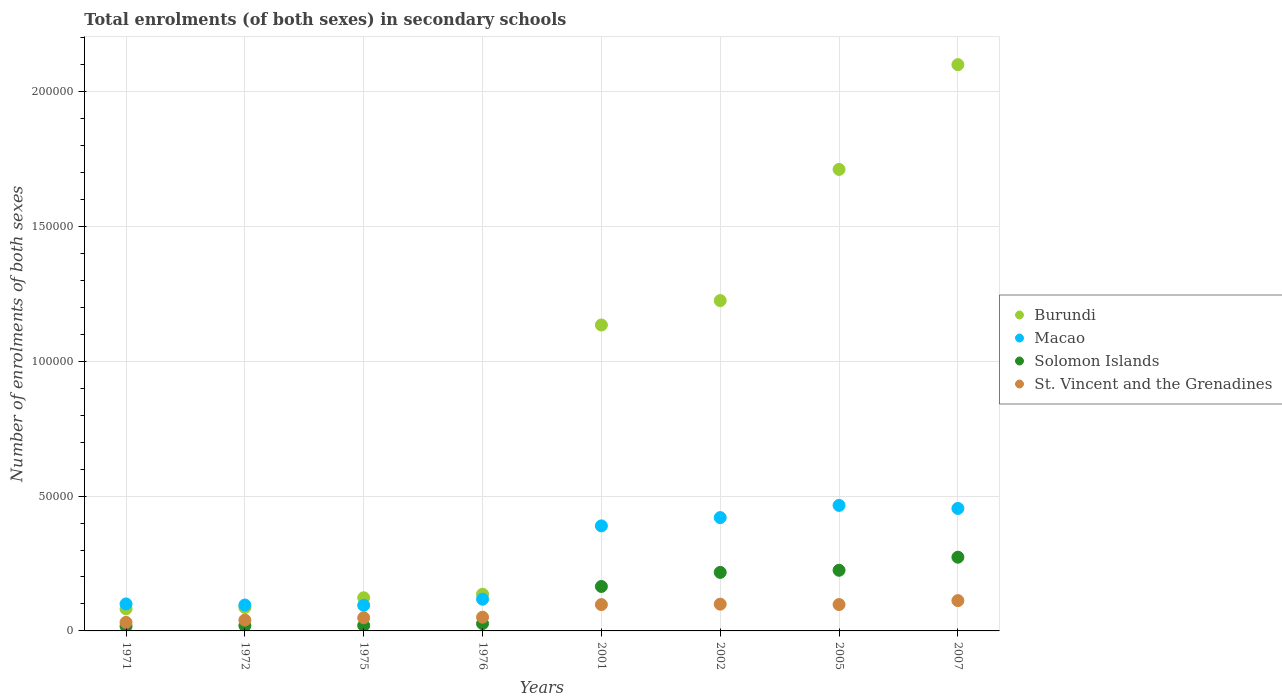How many different coloured dotlines are there?
Your answer should be very brief. 4. What is the number of enrolments in secondary schools in Solomon Islands in 1976?
Offer a very short reply. 2725. Across all years, what is the maximum number of enrolments in secondary schools in Solomon Islands?
Give a very brief answer. 2.73e+04. Across all years, what is the minimum number of enrolments in secondary schools in Burundi?
Your answer should be compact. 8169. In which year was the number of enrolments in secondary schools in Macao minimum?
Provide a succinct answer. 1975. What is the total number of enrolments in secondary schools in Solomon Islands in the graph?
Provide a succinct answer. 9.64e+04. What is the difference between the number of enrolments in secondary schools in Solomon Islands in 1971 and that in 2007?
Your answer should be very brief. -2.56e+04. What is the difference between the number of enrolments in secondary schools in Macao in 1975 and the number of enrolments in secondary schools in Burundi in 1972?
Keep it short and to the point. 820. What is the average number of enrolments in secondary schools in Macao per year?
Keep it short and to the point. 2.67e+04. In the year 2007, what is the difference between the number of enrolments in secondary schools in Solomon Islands and number of enrolments in secondary schools in Macao?
Your answer should be very brief. -1.81e+04. In how many years, is the number of enrolments in secondary schools in St. Vincent and the Grenadines greater than 120000?
Your answer should be very brief. 0. What is the ratio of the number of enrolments in secondary schools in Macao in 1972 to that in 2002?
Your answer should be compact. 0.23. Is the difference between the number of enrolments in secondary schools in Solomon Islands in 1971 and 1976 greater than the difference between the number of enrolments in secondary schools in Macao in 1971 and 1976?
Your answer should be very brief. Yes. What is the difference between the highest and the second highest number of enrolments in secondary schools in Macao?
Offer a very short reply. 1129. What is the difference between the highest and the lowest number of enrolments in secondary schools in Macao?
Keep it short and to the point. 3.70e+04. In how many years, is the number of enrolments in secondary schools in Macao greater than the average number of enrolments in secondary schools in Macao taken over all years?
Give a very brief answer. 4. Is the sum of the number of enrolments in secondary schools in Solomon Islands in 1975 and 2005 greater than the maximum number of enrolments in secondary schools in Burundi across all years?
Make the answer very short. No. Is it the case that in every year, the sum of the number of enrolments in secondary schools in Solomon Islands and number of enrolments in secondary schools in St. Vincent and the Grenadines  is greater than the sum of number of enrolments in secondary schools in Macao and number of enrolments in secondary schools in Burundi?
Your answer should be very brief. No. Is it the case that in every year, the sum of the number of enrolments in secondary schools in Macao and number of enrolments in secondary schools in St. Vincent and the Grenadines  is greater than the number of enrolments in secondary schools in Burundi?
Your answer should be compact. No. Does the number of enrolments in secondary schools in Solomon Islands monotonically increase over the years?
Your response must be concise. Yes. Is the number of enrolments in secondary schools in Solomon Islands strictly less than the number of enrolments in secondary schools in Macao over the years?
Offer a terse response. Yes. How many dotlines are there?
Offer a very short reply. 4. How many years are there in the graph?
Ensure brevity in your answer.  8. Are the values on the major ticks of Y-axis written in scientific E-notation?
Give a very brief answer. No. Does the graph contain any zero values?
Offer a very short reply. No. Where does the legend appear in the graph?
Your answer should be compact. Center right. How many legend labels are there?
Your answer should be compact. 4. How are the legend labels stacked?
Your response must be concise. Vertical. What is the title of the graph?
Make the answer very short. Total enrolments (of both sexes) in secondary schools. What is the label or title of the X-axis?
Give a very brief answer. Years. What is the label or title of the Y-axis?
Offer a very short reply. Number of enrolments of both sexes. What is the Number of enrolments of both sexes of Burundi in 1971?
Ensure brevity in your answer.  8169. What is the Number of enrolments of both sexes in Macao in 1971?
Ensure brevity in your answer.  1.00e+04. What is the Number of enrolments of both sexes of Solomon Islands in 1971?
Make the answer very short. 1720. What is the Number of enrolments of both sexes of St. Vincent and the Grenadines in 1971?
Your response must be concise. 3158. What is the Number of enrolments of both sexes in Burundi in 1972?
Provide a short and direct response. 8678. What is the Number of enrolments of both sexes in Macao in 1972?
Give a very brief answer. 9606. What is the Number of enrolments of both sexes in Solomon Islands in 1972?
Provide a short and direct response. 1943. What is the Number of enrolments of both sexes of St. Vincent and the Grenadines in 1972?
Your answer should be very brief. 4009. What is the Number of enrolments of both sexes in Burundi in 1975?
Provide a succinct answer. 1.23e+04. What is the Number of enrolments of both sexes of Macao in 1975?
Make the answer very short. 9498. What is the Number of enrolments of both sexes in Solomon Islands in 1975?
Keep it short and to the point. 2014. What is the Number of enrolments of both sexes of St. Vincent and the Grenadines in 1975?
Make the answer very short. 4878. What is the Number of enrolments of both sexes of Burundi in 1976?
Keep it short and to the point. 1.36e+04. What is the Number of enrolments of both sexes of Macao in 1976?
Keep it short and to the point. 1.18e+04. What is the Number of enrolments of both sexes of Solomon Islands in 1976?
Give a very brief answer. 2725. What is the Number of enrolments of both sexes in St. Vincent and the Grenadines in 1976?
Make the answer very short. 5084. What is the Number of enrolments of both sexes of Burundi in 2001?
Offer a very short reply. 1.13e+05. What is the Number of enrolments of both sexes of Macao in 2001?
Offer a terse response. 3.89e+04. What is the Number of enrolments of both sexes of Solomon Islands in 2001?
Your response must be concise. 1.65e+04. What is the Number of enrolments of both sexes of St. Vincent and the Grenadines in 2001?
Give a very brief answer. 9756. What is the Number of enrolments of both sexes in Burundi in 2002?
Your answer should be very brief. 1.22e+05. What is the Number of enrolments of both sexes in Macao in 2002?
Ensure brevity in your answer.  4.20e+04. What is the Number of enrolments of both sexes of Solomon Islands in 2002?
Ensure brevity in your answer.  2.17e+04. What is the Number of enrolments of both sexes of St. Vincent and the Grenadines in 2002?
Give a very brief answer. 9920. What is the Number of enrolments of both sexes of Burundi in 2005?
Your answer should be very brief. 1.71e+05. What is the Number of enrolments of both sexes in Macao in 2005?
Your answer should be very brief. 4.65e+04. What is the Number of enrolments of both sexes in Solomon Islands in 2005?
Your response must be concise. 2.25e+04. What is the Number of enrolments of both sexes of St. Vincent and the Grenadines in 2005?
Keep it short and to the point. 9780. What is the Number of enrolments of both sexes in Burundi in 2007?
Ensure brevity in your answer.  2.10e+05. What is the Number of enrolments of both sexes of Macao in 2007?
Provide a succinct answer. 4.54e+04. What is the Number of enrolments of both sexes of Solomon Islands in 2007?
Your answer should be compact. 2.73e+04. What is the Number of enrolments of both sexes of St. Vincent and the Grenadines in 2007?
Your answer should be compact. 1.12e+04. Across all years, what is the maximum Number of enrolments of both sexes of Burundi?
Offer a terse response. 2.10e+05. Across all years, what is the maximum Number of enrolments of both sexes of Macao?
Your answer should be very brief. 4.65e+04. Across all years, what is the maximum Number of enrolments of both sexes in Solomon Islands?
Offer a very short reply. 2.73e+04. Across all years, what is the maximum Number of enrolments of both sexes of St. Vincent and the Grenadines?
Make the answer very short. 1.12e+04. Across all years, what is the minimum Number of enrolments of both sexes in Burundi?
Give a very brief answer. 8169. Across all years, what is the minimum Number of enrolments of both sexes in Macao?
Keep it short and to the point. 9498. Across all years, what is the minimum Number of enrolments of both sexes in Solomon Islands?
Ensure brevity in your answer.  1720. Across all years, what is the minimum Number of enrolments of both sexes in St. Vincent and the Grenadines?
Give a very brief answer. 3158. What is the total Number of enrolments of both sexes in Burundi in the graph?
Your answer should be compact. 6.60e+05. What is the total Number of enrolments of both sexes of Macao in the graph?
Give a very brief answer. 2.14e+05. What is the total Number of enrolments of both sexes in Solomon Islands in the graph?
Ensure brevity in your answer.  9.64e+04. What is the total Number of enrolments of both sexes of St. Vincent and the Grenadines in the graph?
Offer a terse response. 5.78e+04. What is the difference between the Number of enrolments of both sexes of Burundi in 1971 and that in 1972?
Make the answer very short. -509. What is the difference between the Number of enrolments of both sexes of Macao in 1971 and that in 1972?
Provide a short and direct response. 401. What is the difference between the Number of enrolments of both sexes of Solomon Islands in 1971 and that in 1972?
Offer a very short reply. -223. What is the difference between the Number of enrolments of both sexes of St. Vincent and the Grenadines in 1971 and that in 1972?
Ensure brevity in your answer.  -851. What is the difference between the Number of enrolments of both sexes in Burundi in 1971 and that in 1975?
Keep it short and to the point. -4128. What is the difference between the Number of enrolments of both sexes of Macao in 1971 and that in 1975?
Offer a terse response. 509. What is the difference between the Number of enrolments of both sexes of Solomon Islands in 1971 and that in 1975?
Make the answer very short. -294. What is the difference between the Number of enrolments of both sexes in St. Vincent and the Grenadines in 1971 and that in 1975?
Make the answer very short. -1720. What is the difference between the Number of enrolments of both sexes in Burundi in 1971 and that in 1976?
Make the answer very short. -5454. What is the difference between the Number of enrolments of both sexes of Macao in 1971 and that in 1976?
Give a very brief answer. -1751. What is the difference between the Number of enrolments of both sexes of Solomon Islands in 1971 and that in 1976?
Ensure brevity in your answer.  -1005. What is the difference between the Number of enrolments of both sexes in St. Vincent and the Grenadines in 1971 and that in 1976?
Keep it short and to the point. -1926. What is the difference between the Number of enrolments of both sexes in Burundi in 1971 and that in 2001?
Ensure brevity in your answer.  -1.05e+05. What is the difference between the Number of enrolments of both sexes in Macao in 1971 and that in 2001?
Your answer should be very brief. -2.89e+04. What is the difference between the Number of enrolments of both sexes of Solomon Islands in 1971 and that in 2001?
Your response must be concise. -1.48e+04. What is the difference between the Number of enrolments of both sexes in St. Vincent and the Grenadines in 1971 and that in 2001?
Keep it short and to the point. -6598. What is the difference between the Number of enrolments of both sexes of Burundi in 1971 and that in 2002?
Give a very brief answer. -1.14e+05. What is the difference between the Number of enrolments of both sexes in Macao in 1971 and that in 2002?
Ensure brevity in your answer.  -3.20e+04. What is the difference between the Number of enrolments of both sexes of Solomon Islands in 1971 and that in 2002?
Offer a terse response. -2.00e+04. What is the difference between the Number of enrolments of both sexes of St. Vincent and the Grenadines in 1971 and that in 2002?
Give a very brief answer. -6762. What is the difference between the Number of enrolments of both sexes in Burundi in 1971 and that in 2005?
Your response must be concise. -1.63e+05. What is the difference between the Number of enrolments of both sexes of Macao in 1971 and that in 2005?
Give a very brief answer. -3.65e+04. What is the difference between the Number of enrolments of both sexes of Solomon Islands in 1971 and that in 2005?
Provide a short and direct response. -2.08e+04. What is the difference between the Number of enrolments of both sexes of St. Vincent and the Grenadines in 1971 and that in 2005?
Your answer should be compact. -6622. What is the difference between the Number of enrolments of both sexes in Burundi in 1971 and that in 2007?
Ensure brevity in your answer.  -2.02e+05. What is the difference between the Number of enrolments of both sexes in Macao in 1971 and that in 2007?
Offer a very short reply. -3.54e+04. What is the difference between the Number of enrolments of both sexes of Solomon Islands in 1971 and that in 2007?
Provide a succinct answer. -2.56e+04. What is the difference between the Number of enrolments of both sexes of St. Vincent and the Grenadines in 1971 and that in 2007?
Give a very brief answer. -8080. What is the difference between the Number of enrolments of both sexes in Burundi in 1972 and that in 1975?
Your answer should be compact. -3619. What is the difference between the Number of enrolments of both sexes in Macao in 1972 and that in 1975?
Make the answer very short. 108. What is the difference between the Number of enrolments of both sexes of Solomon Islands in 1972 and that in 1975?
Your answer should be very brief. -71. What is the difference between the Number of enrolments of both sexes of St. Vincent and the Grenadines in 1972 and that in 1975?
Make the answer very short. -869. What is the difference between the Number of enrolments of both sexes of Burundi in 1972 and that in 1976?
Make the answer very short. -4945. What is the difference between the Number of enrolments of both sexes of Macao in 1972 and that in 1976?
Your response must be concise. -2152. What is the difference between the Number of enrolments of both sexes of Solomon Islands in 1972 and that in 1976?
Provide a short and direct response. -782. What is the difference between the Number of enrolments of both sexes of St. Vincent and the Grenadines in 1972 and that in 1976?
Provide a short and direct response. -1075. What is the difference between the Number of enrolments of both sexes in Burundi in 1972 and that in 2001?
Ensure brevity in your answer.  -1.05e+05. What is the difference between the Number of enrolments of both sexes in Macao in 1972 and that in 2001?
Make the answer very short. -2.93e+04. What is the difference between the Number of enrolments of both sexes in Solomon Islands in 1972 and that in 2001?
Your answer should be very brief. -1.45e+04. What is the difference between the Number of enrolments of both sexes of St. Vincent and the Grenadines in 1972 and that in 2001?
Keep it short and to the point. -5747. What is the difference between the Number of enrolments of both sexes in Burundi in 1972 and that in 2002?
Ensure brevity in your answer.  -1.14e+05. What is the difference between the Number of enrolments of both sexes in Macao in 1972 and that in 2002?
Give a very brief answer. -3.24e+04. What is the difference between the Number of enrolments of both sexes in Solomon Islands in 1972 and that in 2002?
Keep it short and to the point. -1.98e+04. What is the difference between the Number of enrolments of both sexes of St. Vincent and the Grenadines in 1972 and that in 2002?
Your answer should be compact. -5911. What is the difference between the Number of enrolments of both sexes in Burundi in 1972 and that in 2005?
Make the answer very short. -1.62e+05. What is the difference between the Number of enrolments of both sexes of Macao in 1972 and that in 2005?
Your answer should be compact. -3.69e+04. What is the difference between the Number of enrolments of both sexes of Solomon Islands in 1972 and that in 2005?
Give a very brief answer. -2.05e+04. What is the difference between the Number of enrolments of both sexes in St. Vincent and the Grenadines in 1972 and that in 2005?
Your answer should be very brief. -5771. What is the difference between the Number of enrolments of both sexes of Burundi in 1972 and that in 2007?
Provide a succinct answer. -2.01e+05. What is the difference between the Number of enrolments of both sexes in Macao in 1972 and that in 2007?
Make the answer very short. -3.58e+04. What is the difference between the Number of enrolments of both sexes in Solomon Islands in 1972 and that in 2007?
Offer a terse response. -2.54e+04. What is the difference between the Number of enrolments of both sexes of St. Vincent and the Grenadines in 1972 and that in 2007?
Ensure brevity in your answer.  -7229. What is the difference between the Number of enrolments of both sexes in Burundi in 1975 and that in 1976?
Your answer should be very brief. -1326. What is the difference between the Number of enrolments of both sexes of Macao in 1975 and that in 1976?
Ensure brevity in your answer.  -2260. What is the difference between the Number of enrolments of both sexes of Solomon Islands in 1975 and that in 1976?
Provide a succinct answer. -711. What is the difference between the Number of enrolments of both sexes in St. Vincent and the Grenadines in 1975 and that in 1976?
Your answer should be very brief. -206. What is the difference between the Number of enrolments of both sexes of Burundi in 1975 and that in 2001?
Offer a terse response. -1.01e+05. What is the difference between the Number of enrolments of both sexes in Macao in 1975 and that in 2001?
Ensure brevity in your answer.  -2.94e+04. What is the difference between the Number of enrolments of both sexes in Solomon Islands in 1975 and that in 2001?
Offer a terse response. -1.45e+04. What is the difference between the Number of enrolments of both sexes of St. Vincent and the Grenadines in 1975 and that in 2001?
Your answer should be compact. -4878. What is the difference between the Number of enrolments of both sexes of Burundi in 1975 and that in 2002?
Make the answer very short. -1.10e+05. What is the difference between the Number of enrolments of both sexes of Macao in 1975 and that in 2002?
Make the answer very short. -3.25e+04. What is the difference between the Number of enrolments of both sexes of Solomon Islands in 1975 and that in 2002?
Offer a very short reply. -1.97e+04. What is the difference between the Number of enrolments of both sexes of St. Vincent and the Grenadines in 1975 and that in 2002?
Your answer should be compact. -5042. What is the difference between the Number of enrolments of both sexes in Burundi in 1975 and that in 2005?
Your answer should be compact. -1.59e+05. What is the difference between the Number of enrolments of both sexes in Macao in 1975 and that in 2005?
Keep it short and to the point. -3.70e+04. What is the difference between the Number of enrolments of both sexes of Solomon Islands in 1975 and that in 2005?
Offer a very short reply. -2.05e+04. What is the difference between the Number of enrolments of both sexes in St. Vincent and the Grenadines in 1975 and that in 2005?
Provide a succinct answer. -4902. What is the difference between the Number of enrolments of both sexes of Burundi in 1975 and that in 2007?
Offer a very short reply. -1.98e+05. What is the difference between the Number of enrolments of both sexes in Macao in 1975 and that in 2007?
Provide a succinct answer. -3.59e+04. What is the difference between the Number of enrolments of both sexes of Solomon Islands in 1975 and that in 2007?
Ensure brevity in your answer.  -2.53e+04. What is the difference between the Number of enrolments of both sexes in St. Vincent and the Grenadines in 1975 and that in 2007?
Offer a terse response. -6360. What is the difference between the Number of enrolments of both sexes of Burundi in 1976 and that in 2001?
Offer a very short reply. -9.98e+04. What is the difference between the Number of enrolments of both sexes in Macao in 1976 and that in 2001?
Provide a short and direct response. -2.72e+04. What is the difference between the Number of enrolments of both sexes in Solomon Islands in 1976 and that in 2001?
Provide a short and direct response. -1.38e+04. What is the difference between the Number of enrolments of both sexes of St. Vincent and the Grenadines in 1976 and that in 2001?
Ensure brevity in your answer.  -4672. What is the difference between the Number of enrolments of both sexes in Burundi in 1976 and that in 2002?
Your answer should be compact. -1.09e+05. What is the difference between the Number of enrolments of both sexes in Macao in 1976 and that in 2002?
Your response must be concise. -3.03e+04. What is the difference between the Number of enrolments of both sexes of Solomon Islands in 1976 and that in 2002?
Offer a very short reply. -1.90e+04. What is the difference between the Number of enrolments of both sexes of St. Vincent and the Grenadines in 1976 and that in 2002?
Give a very brief answer. -4836. What is the difference between the Number of enrolments of both sexes in Burundi in 1976 and that in 2005?
Your answer should be very brief. -1.57e+05. What is the difference between the Number of enrolments of both sexes in Macao in 1976 and that in 2005?
Your response must be concise. -3.48e+04. What is the difference between the Number of enrolments of both sexes in Solomon Islands in 1976 and that in 2005?
Provide a short and direct response. -1.98e+04. What is the difference between the Number of enrolments of both sexes in St. Vincent and the Grenadines in 1976 and that in 2005?
Offer a very short reply. -4696. What is the difference between the Number of enrolments of both sexes of Burundi in 1976 and that in 2007?
Give a very brief answer. -1.96e+05. What is the difference between the Number of enrolments of both sexes of Macao in 1976 and that in 2007?
Give a very brief answer. -3.37e+04. What is the difference between the Number of enrolments of both sexes in Solomon Islands in 1976 and that in 2007?
Offer a very short reply. -2.46e+04. What is the difference between the Number of enrolments of both sexes in St. Vincent and the Grenadines in 1976 and that in 2007?
Give a very brief answer. -6154. What is the difference between the Number of enrolments of both sexes in Burundi in 2001 and that in 2002?
Keep it short and to the point. -9042. What is the difference between the Number of enrolments of both sexes in Macao in 2001 and that in 2002?
Make the answer very short. -3074. What is the difference between the Number of enrolments of both sexes in Solomon Islands in 2001 and that in 2002?
Provide a short and direct response. -5220. What is the difference between the Number of enrolments of both sexes of St. Vincent and the Grenadines in 2001 and that in 2002?
Provide a short and direct response. -164. What is the difference between the Number of enrolments of both sexes in Burundi in 2001 and that in 2005?
Provide a short and direct response. -5.77e+04. What is the difference between the Number of enrolments of both sexes of Macao in 2001 and that in 2005?
Provide a succinct answer. -7596. What is the difference between the Number of enrolments of both sexes of Solomon Islands in 2001 and that in 2005?
Make the answer very short. -6007. What is the difference between the Number of enrolments of both sexes in St. Vincent and the Grenadines in 2001 and that in 2005?
Offer a terse response. -24. What is the difference between the Number of enrolments of both sexes of Burundi in 2001 and that in 2007?
Give a very brief answer. -9.65e+04. What is the difference between the Number of enrolments of both sexes of Macao in 2001 and that in 2007?
Give a very brief answer. -6467. What is the difference between the Number of enrolments of both sexes of Solomon Islands in 2001 and that in 2007?
Your answer should be compact. -1.09e+04. What is the difference between the Number of enrolments of both sexes in St. Vincent and the Grenadines in 2001 and that in 2007?
Make the answer very short. -1482. What is the difference between the Number of enrolments of both sexes of Burundi in 2002 and that in 2005?
Your answer should be very brief. -4.86e+04. What is the difference between the Number of enrolments of both sexes in Macao in 2002 and that in 2005?
Make the answer very short. -4522. What is the difference between the Number of enrolments of both sexes in Solomon Islands in 2002 and that in 2005?
Keep it short and to the point. -787. What is the difference between the Number of enrolments of both sexes of St. Vincent and the Grenadines in 2002 and that in 2005?
Your answer should be compact. 140. What is the difference between the Number of enrolments of both sexes of Burundi in 2002 and that in 2007?
Your answer should be compact. -8.75e+04. What is the difference between the Number of enrolments of both sexes in Macao in 2002 and that in 2007?
Your answer should be very brief. -3393. What is the difference between the Number of enrolments of both sexes of Solomon Islands in 2002 and that in 2007?
Keep it short and to the point. -5632. What is the difference between the Number of enrolments of both sexes of St. Vincent and the Grenadines in 2002 and that in 2007?
Give a very brief answer. -1318. What is the difference between the Number of enrolments of both sexes in Burundi in 2005 and that in 2007?
Offer a very short reply. -3.88e+04. What is the difference between the Number of enrolments of both sexes of Macao in 2005 and that in 2007?
Give a very brief answer. 1129. What is the difference between the Number of enrolments of both sexes in Solomon Islands in 2005 and that in 2007?
Provide a short and direct response. -4845. What is the difference between the Number of enrolments of both sexes of St. Vincent and the Grenadines in 2005 and that in 2007?
Your answer should be very brief. -1458. What is the difference between the Number of enrolments of both sexes of Burundi in 1971 and the Number of enrolments of both sexes of Macao in 1972?
Make the answer very short. -1437. What is the difference between the Number of enrolments of both sexes in Burundi in 1971 and the Number of enrolments of both sexes in Solomon Islands in 1972?
Your answer should be compact. 6226. What is the difference between the Number of enrolments of both sexes in Burundi in 1971 and the Number of enrolments of both sexes in St. Vincent and the Grenadines in 1972?
Offer a very short reply. 4160. What is the difference between the Number of enrolments of both sexes of Macao in 1971 and the Number of enrolments of both sexes of Solomon Islands in 1972?
Your answer should be very brief. 8064. What is the difference between the Number of enrolments of both sexes of Macao in 1971 and the Number of enrolments of both sexes of St. Vincent and the Grenadines in 1972?
Your response must be concise. 5998. What is the difference between the Number of enrolments of both sexes of Solomon Islands in 1971 and the Number of enrolments of both sexes of St. Vincent and the Grenadines in 1972?
Make the answer very short. -2289. What is the difference between the Number of enrolments of both sexes of Burundi in 1971 and the Number of enrolments of both sexes of Macao in 1975?
Your response must be concise. -1329. What is the difference between the Number of enrolments of both sexes of Burundi in 1971 and the Number of enrolments of both sexes of Solomon Islands in 1975?
Give a very brief answer. 6155. What is the difference between the Number of enrolments of both sexes of Burundi in 1971 and the Number of enrolments of both sexes of St. Vincent and the Grenadines in 1975?
Make the answer very short. 3291. What is the difference between the Number of enrolments of both sexes in Macao in 1971 and the Number of enrolments of both sexes in Solomon Islands in 1975?
Make the answer very short. 7993. What is the difference between the Number of enrolments of both sexes of Macao in 1971 and the Number of enrolments of both sexes of St. Vincent and the Grenadines in 1975?
Offer a very short reply. 5129. What is the difference between the Number of enrolments of both sexes in Solomon Islands in 1971 and the Number of enrolments of both sexes in St. Vincent and the Grenadines in 1975?
Your answer should be very brief. -3158. What is the difference between the Number of enrolments of both sexes in Burundi in 1971 and the Number of enrolments of both sexes in Macao in 1976?
Offer a very short reply. -3589. What is the difference between the Number of enrolments of both sexes in Burundi in 1971 and the Number of enrolments of both sexes in Solomon Islands in 1976?
Keep it short and to the point. 5444. What is the difference between the Number of enrolments of both sexes in Burundi in 1971 and the Number of enrolments of both sexes in St. Vincent and the Grenadines in 1976?
Your response must be concise. 3085. What is the difference between the Number of enrolments of both sexes of Macao in 1971 and the Number of enrolments of both sexes of Solomon Islands in 1976?
Offer a terse response. 7282. What is the difference between the Number of enrolments of both sexes in Macao in 1971 and the Number of enrolments of both sexes in St. Vincent and the Grenadines in 1976?
Keep it short and to the point. 4923. What is the difference between the Number of enrolments of both sexes in Solomon Islands in 1971 and the Number of enrolments of both sexes in St. Vincent and the Grenadines in 1976?
Make the answer very short. -3364. What is the difference between the Number of enrolments of both sexes in Burundi in 1971 and the Number of enrolments of both sexes in Macao in 2001?
Ensure brevity in your answer.  -3.08e+04. What is the difference between the Number of enrolments of both sexes of Burundi in 1971 and the Number of enrolments of both sexes of Solomon Islands in 2001?
Make the answer very short. -8311. What is the difference between the Number of enrolments of both sexes in Burundi in 1971 and the Number of enrolments of both sexes in St. Vincent and the Grenadines in 2001?
Your answer should be compact. -1587. What is the difference between the Number of enrolments of both sexes of Macao in 1971 and the Number of enrolments of both sexes of Solomon Islands in 2001?
Your response must be concise. -6473. What is the difference between the Number of enrolments of both sexes in Macao in 1971 and the Number of enrolments of both sexes in St. Vincent and the Grenadines in 2001?
Offer a terse response. 251. What is the difference between the Number of enrolments of both sexes of Solomon Islands in 1971 and the Number of enrolments of both sexes of St. Vincent and the Grenadines in 2001?
Give a very brief answer. -8036. What is the difference between the Number of enrolments of both sexes of Burundi in 1971 and the Number of enrolments of both sexes of Macao in 2002?
Ensure brevity in your answer.  -3.38e+04. What is the difference between the Number of enrolments of both sexes in Burundi in 1971 and the Number of enrolments of both sexes in Solomon Islands in 2002?
Your response must be concise. -1.35e+04. What is the difference between the Number of enrolments of both sexes of Burundi in 1971 and the Number of enrolments of both sexes of St. Vincent and the Grenadines in 2002?
Your answer should be very brief. -1751. What is the difference between the Number of enrolments of both sexes of Macao in 1971 and the Number of enrolments of both sexes of Solomon Islands in 2002?
Your response must be concise. -1.17e+04. What is the difference between the Number of enrolments of both sexes of Solomon Islands in 1971 and the Number of enrolments of both sexes of St. Vincent and the Grenadines in 2002?
Give a very brief answer. -8200. What is the difference between the Number of enrolments of both sexes of Burundi in 1971 and the Number of enrolments of both sexes of Macao in 2005?
Your answer should be compact. -3.84e+04. What is the difference between the Number of enrolments of both sexes in Burundi in 1971 and the Number of enrolments of both sexes in Solomon Islands in 2005?
Offer a very short reply. -1.43e+04. What is the difference between the Number of enrolments of both sexes of Burundi in 1971 and the Number of enrolments of both sexes of St. Vincent and the Grenadines in 2005?
Provide a short and direct response. -1611. What is the difference between the Number of enrolments of both sexes of Macao in 1971 and the Number of enrolments of both sexes of Solomon Islands in 2005?
Your response must be concise. -1.25e+04. What is the difference between the Number of enrolments of both sexes in Macao in 1971 and the Number of enrolments of both sexes in St. Vincent and the Grenadines in 2005?
Offer a terse response. 227. What is the difference between the Number of enrolments of both sexes in Solomon Islands in 1971 and the Number of enrolments of both sexes in St. Vincent and the Grenadines in 2005?
Offer a terse response. -8060. What is the difference between the Number of enrolments of both sexes of Burundi in 1971 and the Number of enrolments of both sexes of Macao in 2007?
Your response must be concise. -3.72e+04. What is the difference between the Number of enrolments of both sexes in Burundi in 1971 and the Number of enrolments of both sexes in Solomon Islands in 2007?
Your response must be concise. -1.92e+04. What is the difference between the Number of enrolments of both sexes of Burundi in 1971 and the Number of enrolments of both sexes of St. Vincent and the Grenadines in 2007?
Provide a succinct answer. -3069. What is the difference between the Number of enrolments of both sexes in Macao in 1971 and the Number of enrolments of both sexes in Solomon Islands in 2007?
Provide a short and direct response. -1.73e+04. What is the difference between the Number of enrolments of both sexes of Macao in 1971 and the Number of enrolments of both sexes of St. Vincent and the Grenadines in 2007?
Provide a short and direct response. -1231. What is the difference between the Number of enrolments of both sexes in Solomon Islands in 1971 and the Number of enrolments of both sexes in St. Vincent and the Grenadines in 2007?
Your answer should be compact. -9518. What is the difference between the Number of enrolments of both sexes of Burundi in 1972 and the Number of enrolments of both sexes of Macao in 1975?
Make the answer very short. -820. What is the difference between the Number of enrolments of both sexes of Burundi in 1972 and the Number of enrolments of both sexes of Solomon Islands in 1975?
Provide a succinct answer. 6664. What is the difference between the Number of enrolments of both sexes in Burundi in 1972 and the Number of enrolments of both sexes in St. Vincent and the Grenadines in 1975?
Offer a very short reply. 3800. What is the difference between the Number of enrolments of both sexes of Macao in 1972 and the Number of enrolments of both sexes of Solomon Islands in 1975?
Ensure brevity in your answer.  7592. What is the difference between the Number of enrolments of both sexes in Macao in 1972 and the Number of enrolments of both sexes in St. Vincent and the Grenadines in 1975?
Your answer should be very brief. 4728. What is the difference between the Number of enrolments of both sexes in Solomon Islands in 1972 and the Number of enrolments of both sexes in St. Vincent and the Grenadines in 1975?
Your response must be concise. -2935. What is the difference between the Number of enrolments of both sexes in Burundi in 1972 and the Number of enrolments of both sexes in Macao in 1976?
Give a very brief answer. -3080. What is the difference between the Number of enrolments of both sexes in Burundi in 1972 and the Number of enrolments of both sexes in Solomon Islands in 1976?
Keep it short and to the point. 5953. What is the difference between the Number of enrolments of both sexes of Burundi in 1972 and the Number of enrolments of both sexes of St. Vincent and the Grenadines in 1976?
Offer a very short reply. 3594. What is the difference between the Number of enrolments of both sexes of Macao in 1972 and the Number of enrolments of both sexes of Solomon Islands in 1976?
Provide a short and direct response. 6881. What is the difference between the Number of enrolments of both sexes of Macao in 1972 and the Number of enrolments of both sexes of St. Vincent and the Grenadines in 1976?
Your answer should be compact. 4522. What is the difference between the Number of enrolments of both sexes of Solomon Islands in 1972 and the Number of enrolments of both sexes of St. Vincent and the Grenadines in 1976?
Make the answer very short. -3141. What is the difference between the Number of enrolments of both sexes of Burundi in 1972 and the Number of enrolments of both sexes of Macao in 2001?
Your answer should be very brief. -3.03e+04. What is the difference between the Number of enrolments of both sexes in Burundi in 1972 and the Number of enrolments of both sexes in Solomon Islands in 2001?
Give a very brief answer. -7802. What is the difference between the Number of enrolments of both sexes of Burundi in 1972 and the Number of enrolments of both sexes of St. Vincent and the Grenadines in 2001?
Make the answer very short. -1078. What is the difference between the Number of enrolments of both sexes of Macao in 1972 and the Number of enrolments of both sexes of Solomon Islands in 2001?
Provide a succinct answer. -6874. What is the difference between the Number of enrolments of both sexes of Macao in 1972 and the Number of enrolments of both sexes of St. Vincent and the Grenadines in 2001?
Offer a very short reply. -150. What is the difference between the Number of enrolments of both sexes in Solomon Islands in 1972 and the Number of enrolments of both sexes in St. Vincent and the Grenadines in 2001?
Your answer should be compact. -7813. What is the difference between the Number of enrolments of both sexes of Burundi in 1972 and the Number of enrolments of both sexes of Macao in 2002?
Ensure brevity in your answer.  -3.33e+04. What is the difference between the Number of enrolments of both sexes of Burundi in 1972 and the Number of enrolments of both sexes of Solomon Islands in 2002?
Offer a terse response. -1.30e+04. What is the difference between the Number of enrolments of both sexes of Burundi in 1972 and the Number of enrolments of both sexes of St. Vincent and the Grenadines in 2002?
Offer a terse response. -1242. What is the difference between the Number of enrolments of both sexes in Macao in 1972 and the Number of enrolments of both sexes in Solomon Islands in 2002?
Your answer should be compact. -1.21e+04. What is the difference between the Number of enrolments of both sexes in Macao in 1972 and the Number of enrolments of both sexes in St. Vincent and the Grenadines in 2002?
Provide a succinct answer. -314. What is the difference between the Number of enrolments of both sexes of Solomon Islands in 1972 and the Number of enrolments of both sexes of St. Vincent and the Grenadines in 2002?
Your answer should be very brief. -7977. What is the difference between the Number of enrolments of both sexes of Burundi in 1972 and the Number of enrolments of both sexes of Macao in 2005?
Your answer should be very brief. -3.79e+04. What is the difference between the Number of enrolments of both sexes of Burundi in 1972 and the Number of enrolments of both sexes of Solomon Islands in 2005?
Keep it short and to the point. -1.38e+04. What is the difference between the Number of enrolments of both sexes in Burundi in 1972 and the Number of enrolments of both sexes in St. Vincent and the Grenadines in 2005?
Provide a succinct answer. -1102. What is the difference between the Number of enrolments of both sexes in Macao in 1972 and the Number of enrolments of both sexes in Solomon Islands in 2005?
Offer a terse response. -1.29e+04. What is the difference between the Number of enrolments of both sexes in Macao in 1972 and the Number of enrolments of both sexes in St. Vincent and the Grenadines in 2005?
Provide a succinct answer. -174. What is the difference between the Number of enrolments of both sexes in Solomon Islands in 1972 and the Number of enrolments of both sexes in St. Vincent and the Grenadines in 2005?
Provide a short and direct response. -7837. What is the difference between the Number of enrolments of both sexes in Burundi in 1972 and the Number of enrolments of both sexes in Macao in 2007?
Offer a very short reply. -3.67e+04. What is the difference between the Number of enrolments of both sexes in Burundi in 1972 and the Number of enrolments of both sexes in Solomon Islands in 2007?
Offer a very short reply. -1.87e+04. What is the difference between the Number of enrolments of both sexes of Burundi in 1972 and the Number of enrolments of both sexes of St. Vincent and the Grenadines in 2007?
Keep it short and to the point. -2560. What is the difference between the Number of enrolments of both sexes of Macao in 1972 and the Number of enrolments of both sexes of Solomon Islands in 2007?
Offer a terse response. -1.77e+04. What is the difference between the Number of enrolments of both sexes of Macao in 1972 and the Number of enrolments of both sexes of St. Vincent and the Grenadines in 2007?
Keep it short and to the point. -1632. What is the difference between the Number of enrolments of both sexes of Solomon Islands in 1972 and the Number of enrolments of both sexes of St. Vincent and the Grenadines in 2007?
Ensure brevity in your answer.  -9295. What is the difference between the Number of enrolments of both sexes of Burundi in 1975 and the Number of enrolments of both sexes of Macao in 1976?
Provide a short and direct response. 539. What is the difference between the Number of enrolments of both sexes in Burundi in 1975 and the Number of enrolments of both sexes in Solomon Islands in 1976?
Offer a terse response. 9572. What is the difference between the Number of enrolments of both sexes in Burundi in 1975 and the Number of enrolments of both sexes in St. Vincent and the Grenadines in 1976?
Give a very brief answer. 7213. What is the difference between the Number of enrolments of both sexes in Macao in 1975 and the Number of enrolments of both sexes in Solomon Islands in 1976?
Provide a succinct answer. 6773. What is the difference between the Number of enrolments of both sexes in Macao in 1975 and the Number of enrolments of both sexes in St. Vincent and the Grenadines in 1976?
Make the answer very short. 4414. What is the difference between the Number of enrolments of both sexes in Solomon Islands in 1975 and the Number of enrolments of both sexes in St. Vincent and the Grenadines in 1976?
Keep it short and to the point. -3070. What is the difference between the Number of enrolments of both sexes of Burundi in 1975 and the Number of enrolments of both sexes of Macao in 2001?
Provide a short and direct response. -2.66e+04. What is the difference between the Number of enrolments of both sexes in Burundi in 1975 and the Number of enrolments of both sexes in Solomon Islands in 2001?
Your answer should be compact. -4183. What is the difference between the Number of enrolments of both sexes of Burundi in 1975 and the Number of enrolments of both sexes of St. Vincent and the Grenadines in 2001?
Ensure brevity in your answer.  2541. What is the difference between the Number of enrolments of both sexes of Macao in 1975 and the Number of enrolments of both sexes of Solomon Islands in 2001?
Provide a succinct answer. -6982. What is the difference between the Number of enrolments of both sexes of Macao in 1975 and the Number of enrolments of both sexes of St. Vincent and the Grenadines in 2001?
Give a very brief answer. -258. What is the difference between the Number of enrolments of both sexes of Solomon Islands in 1975 and the Number of enrolments of both sexes of St. Vincent and the Grenadines in 2001?
Ensure brevity in your answer.  -7742. What is the difference between the Number of enrolments of both sexes of Burundi in 1975 and the Number of enrolments of both sexes of Macao in 2002?
Ensure brevity in your answer.  -2.97e+04. What is the difference between the Number of enrolments of both sexes of Burundi in 1975 and the Number of enrolments of both sexes of Solomon Islands in 2002?
Provide a succinct answer. -9403. What is the difference between the Number of enrolments of both sexes of Burundi in 1975 and the Number of enrolments of both sexes of St. Vincent and the Grenadines in 2002?
Make the answer very short. 2377. What is the difference between the Number of enrolments of both sexes of Macao in 1975 and the Number of enrolments of both sexes of Solomon Islands in 2002?
Offer a very short reply. -1.22e+04. What is the difference between the Number of enrolments of both sexes of Macao in 1975 and the Number of enrolments of both sexes of St. Vincent and the Grenadines in 2002?
Ensure brevity in your answer.  -422. What is the difference between the Number of enrolments of both sexes of Solomon Islands in 1975 and the Number of enrolments of both sexes of St. Vincent and the Grenadines in 2002?
Offer a terse response. -7906. What is the difference between the Number of enrolments of both sexes of Burundi in 1975 and the Number of enrolments of both sexes of Macao in 2005?
Your response must be concise. -3.42e+04. What is the difference between the Number of enrolments of both sexes of Burundi in 1975 and the Number of enrolments of both sexes of Solomon Islands in 2005?
Your response must be concise. -1.02e+04. What is the difference between the Number of enrolments of both sexes in Burundi in 1975 and the Number of enrolments of both sexes in St. Vincent and the Grenadines in 2005?
Give a very brief answer. 2517. What is the difference between the Number of enrolments of both sexes in Macao in 1975 and the Number of enrolments of both sexes in Solomon Islands in 2005?
Give a very brief answer. -1.30e+04. What is the difference between the Number of enrolments of both sexes in Macao in 1975 and the Number of enrolments of both sexes in St. Vincent and the Grenadines in 2005?
Give a very brief answer. -282. What is the difference between the Number of enrolments of both sexes of Solomon Islands in 1975 and the Number of enrolments of both sexes of St. Vincent and the Grenadines in 2005?
Offer a very short reply. -7766. What is the difference between the Number of enrolments of both sexes of Burundi in 1975 and the Number of enrolments of both sexes of Macao in 2007?
Ensure brevity in your answer.  -3.31e+04. What is the difference between the Number of enrolments of both sexes in Burundi in 1975 and the Number of enrolments of both sexes in Solomon Islands in 2007?
Your response must be concise. -1.50e+04. What is the difference between the Number of enrolments of both sexes of Burundi in 1975 and the Number of enrolments of both sexes of St. Vincent and the Grenadines in 2007?
Offer a very short reply. 1059. What is the difference between the Number of enrolments of both sexes of Macao in 1975 and the Number of enrolments of both sexes of Solomon Islands in 2007?
Make the answer very short. -1.78e+04. What is the difference between the Number of enrolments of both sexes of Macao in 1975 and the Number of enrolments of both sexes of St. Vincent and the Grenadines in 2007?
Offer a terse response. -1740. What is the difference between the Number of enrolments of both sexes in Solomon Islands in 1975 and the Number of enrolments of both sexes in St. Vincent and the Grenadines in 2007?
Keep it short and to the point. -9224. What is the difference between the Number of enrolments of both sexes of Burundi in 1976 and the Number of enrolments of both sexes of Macao in 2001?
Ensure brevity in your answer.  -2.53e+04. What is the difference between the Number of enrolments of both sexes of Burundi in 1976 and the Number of enrolments of both sexes of Solomon Islands in 2001?
Provide a succinct answer. -2857. What is the difference between the Number of enrolments of both sexes of Burundi in 1976 and the Number of enrolments of both sexes of St. Vincent and the Grenadines in 2001?
Provide a succinct answer. 3867. What is the difference between the Number of enrolments of both sexes in Macao in 1976 and the Number of enrolments of both sexes in Solomon Islands in 2001?
Your answer should be very brief. -4722. What is the difference between the Number of enrolments of both sexes in Macao in 1976 and the Number of enrolments of both sexes in St. Vincent and the Grenadines in 2001?
Your answer should be very brief. 2002. What is the difference between the Number of enrolments of both sexes in Solomon Islands in 1976 and the Number of enrolments of both sexes in St. Vincent and the Grenadines in 2001?
Give a very brief answer. -7031. What is the difference between the Number of enrolments of both sexes in Burundi in 1976 and the Number of enrolments of both sexes in Macao in 2002?
Offer a terse response. -2.84e+04. What is the difference between the Number of enrolments of both sexes of Burundi in 1976 and the Number of enrolments of both sexes of Solomon Islands in 2002?
Offer a very short reply. -8077. What is the difference between the Number of enrolments of both sexes of Burundi in 1976 and the Number of enrolments of both sexes of St. Vincent and the Grenadines in 2002?
Provide a succinct answer. 3703. What is the difference between the Number of enrolments of both sexes in Macao in 1976 and the Number of enrolments of both sexes in Solomon Islands in 2002?
Your response must be concise. -9942. What is the difference between the Number of enrolments of both sexes of Macao in 1976 and the Number of enrolments of both sexes of St. Vincent and the Grenadines in 2002?
Your response must be concise. 1838. What is the difference between the Number of enrolments of both sexes of Solomon Islands in 1976 and the Number of enrolments of both sexes of St. Vincent and the Grenadines in 2002?
Provide a succinct answer. -7195. What is the difference between the Number of enrolments of both sexes of Burundi in 1976 and the Number of enrolments of both sexes of Macao in 2005?
Offer a very short reply. -3.29e+04. What is the difference between the Number of enrolments of both sexes in Burundi in 1976 and the Number of enrolments of both sexes in Solomon Islands in 2005?
Give a very brief answer. -8864. What is the difference between the Number of enrolments of both sexes of Burundi in 1976 and the Number of enrolments of both sexes of St. Vincent and the Grenadines in 2005?
Make the answer very short. 3843. What is the difference between the Number of enrolments of both sexes of Macao in 1976 and the Number of enrolments of both sexes of Solomon Islands in 2005?
Your answer should be compact. -1.07e+04. What is the difference between the Number of enrolments of both sexes of Macao in 1976 and the Number of enrolments of both sexes of St. Vincent and the Grenadines in 2005?
Provide a short and direct response. 1978. What is the difference between the Number of enrolments of both sexes in Solomon Islands in 1976 and the Number of enrolments of both sexes in St. Vincent and the Grenadines in 2005?
Your response must be concise. -7055. What is the difference between the Number of enrolments of both sexes in Burundi in 1976 and the Number of enrolments of both sexes in Macao in 2007?
Keep it short and to the point. -3.18e+04. What is the difference between the Number of enrolments of both sexes of Burundi in 1976 and the Number of enrolments of both sexes of Solomon Islands in 2007?
Ensure brevity in your answer.  -1.37e+04. What is the difference between the Number of enrolments of both sexes of Burundi in 1976 and the Number of enrolments of both sexes of St. Vincent and the Grenadines in 2007?
Offer a very short reply. 2385. What is the difference between the Number of enrolments of both sexes of Macao in 1976 and the Number of enrolments of both sexes of Solomon Islands in 2007?
Give a very brief answer. -1.56e+04. What is the difference between the Number of enrolments of both sexes of Macao in 1976 and the Number of enrolments of both sexes of St. Vincent and the Grenadines in 2007?
Offer a very short reply. 520. What is the difference between the Number of enrolments of both sexes of Solomon Islands in 1976 and the Number of enrolments of both sexes of St. Vincent and the Grenadines in 2007?
Offer a very short reply. -8513. What is the difference between the Number of enrolments of both sexes of Burundi in 2001 and the Number of enrolments of both sexes of Macao in 2002?
Ensure brevity in your answer.  7.14e+04. What is the difference between the Number of enrolments of both sexes in Burundi in 2001 and the Number of enrolments of both sexes in Solomon Islands in 2002?
Your response must be concise. 9.17e+04. What is the difference between the Number of enrolments of both sexes in Burundi in 2001 and the Number of enrolments of both sexes in St. Vincent and the Grenadines in 2002?
Your answer should be compact. 1.04e+05. What is the difference between the Number of enrolments of both sexes of Macao in 2001 and the Number of enrolments of both sexes of Solomon Islands in 2002?
Keep it short and to the point. 1.72e+04. What is the difference between the Number of enrolments of both sexes of Macao in 2001 and the Number of enrolments of both sexes of St. Vincent and the Grenadines in 2002?
Ensure brevity in your answer.  2.90e+04. What is the difference between the Number of enrolments of both sexes in Solomon Islands in 2001 and the Number of enrolments of both sexes in St. Vincent and the Grenadines in 2002?
Your response must be concise. 6560. What is the difference between the Number of enrolments of both sexes in Burundi in 2001 and the Number of enrolments of both sexes in Macao in 2005?
Your answer should be very brief. 6.69e+04. What is the difference between the Number of enrolments of both sexes in Burundi in 2001 and the Number of enrolments of both sexes in Solomon Islands in 2005?
Offer a very short reply. 9.09e+04. What is the difference between the Number of enrolments of both sexes in Burundi in 2001 and the Number of enrolments of both sexes in St. Vincent and the Grenadines in 2005?
Make the answer very short. 1.04e+05. What is the difference between the Number of enrolments of both sexes of Macao in 2001 and the Number of enrolments of both sexes of Solomon Islands in 2005?
Provide a short and direct response. 1.65e+04. What is the difference between the Number of enrolments of both sexes of Macao in 2001 and the Number of enrolments of both sexes of St. Vincent and the Grenadines in 2005?
Offer a terse response. 2.92e+04. What is the difference between the Number of enrolments of both sexes in Solomon Islands in 2001 and the Number of enrolments of both sexes in St. Vincent and the Grenadines in 2005?
Ensure brevity in your answer.  6700. What is the difference between the Number of enrolments of both sexes of Burundi in 2001 and the Number of enrolments of both sexes of Macao in 2007?
Your answer should be compact. 6.80e+04. What is the difference between the Number of enrolments of both sexes in Burundi in 2001 and the Number of enrolments of both sexes in Solomon Islands in 2007?
Your answer should be compact. 8.61e+04. What is the difference between the Number of enrolments of both sexes of Burundi in 2001 and the Number of enrolments of both sexes of St. Vincent and the Grenadines in 2007?
Give a very brief answer. 1.02e+05. What is the difference between the Number of enrolments of both sexes in Macao in 2001 and the Number of enrolments of both sexes in Solomon Islands in 2007?
Your answer should be very brief. 1.16e+04. What is the difference between the Number of enrolments of both sexes of Macao in 2001 and the Number of enrolments of both sexes of St. Vincent and the Grenadines in 2007?
Make the answer very short. 2.77e+04. What is the difference between the Number of enrolments of both sexes of Solomon Islands in 2001 and the Number of enrolments of both sexes of St. Vincent and the Grenadines in 2007?
Offer a very short reply. 5242. What is the difference between the Number of enrolments of both sexes of Burundi in 2002 and the Number of enrolments of both sexes of Macao in 2005?
Offer a very short reply. 7.59e+04. What is the difference between the Number of enrolments of both sexes of Burundi in 2002 and the Number of enrolments of both sexes of Solomon Islands in 2005?
Provide a short and direct response. 1.00e+05. What is the difference between the Number of enrolments of both sexes in Burundi in 2002 and the Number of enrolments of both sexes in St. Vincent and the Grenadines in 2005?
Your answer should be compact. 1.13e+05. What is the difference between the Number of enrolments of both sexes of Macao in 2002 and the Number of enrolments of both sexes of Solomon Islands in 2005?
Offer a terse response. 1.95e+04. What is the difference between the Number of enrolments of both sexes of Macao in 2002 and the Number of enrolments of both sexes of St. Vincent and the Grenadines in 2005?
Keep it short and to the point. 3.22e+04. What is the difference between the Number of enrolments of both sexes of Solomon Islands in 2002 and the Number of enrolments of both sexes of St. Vincent and the Grenadines in 2005?
Offer a very short reply. 1.19e+04. What is the difference between the Number of enrolments of both sexes in Burundi in 2002 and the Number of enrolments of both sexes in Macao in 2007?
Make the answer very short. 7.71e+04. What is the difference between the Number of enrolments of both sexes in Burundi in 2002 and the Number of enrolments of both sexes in Solomon Islands in 2007?
Offer a terse response. 9.51e+04. What is the difference between the Number of enrolments of both sexes in Burundi in 2002 and the Number of enrolments of both sexes in St. Vincent and the Grenadines in 2007?
Offer a terse response. 1.11e+05. What is the difference between the Number of enrolments of both sexes in Macao in 2002 and the Number of enrolments of both sexes in Solomon Islands in 2007?
Keep it short and to the point. 1.47e+04. What is the difference between the Number of enrolments of both sexes in Macao in 2002 and the Number of enrolments of both sexes in St. Vincent and the Grenadines in 2007?
Your response must be concise. 3.08e+04. What is the difference between the Number of enrolments of both sexes in Solomon Islands in 2002 and the Number of enrolments of both sexes in St. Vincent and the Grenadines in 2007?
Offer a terse response. 1.05e+04. What is the difference between the Number of enrolments of both sexes in Burundi in 2005 and the Number of enrolments of both sexes in Macao in 2007?
Give a very brief answer. 1.26e+05. What is the difference between the Number of enrolments of both sexes in Burundi in 2005 and the Number of enrolments of both sexes in Solomon Islands in 2007?
Your answer should be very brief. 1.44e+05. What is the difference between the Number of enrolments of both sexes of Burundi in 2005 and the Number of enrolments of both sexes of St. Vincent and the Grenadines in 2007?
Make the answer very short. 1.60e+05. What is the difference between the Number of enrolments of both sexes in Macao in 2005 and the Number of enrolments of both sexes in Solomon Islands in 2007?
Ensure brevity in your answer.  1.92e+04. What is the difference between the Number of enrolments of both sexes in Macao in 2005 and the Number of enrolments of both sexes in St. Vincent and the Grenadines in 2007?
Provide a succinct answer. 3.53e+04. What is the difference between the Number of enrolments of both sexes of Solomon Islands in 2005 and the Number of enrolments of both sexes of St. Vincent and the Grenadines in 2007?
Make the answer very short. 1.12e+04. What is the average Number of enrolments of both sexes in Burundi per year?
Offer a very short reply. 8.25e+04. What is the average Number of enrolments of both sexes of Macao per year?
Ensure brevity in your answer.  2.67e+04. What is the average Number of enrolments of both sexes in Solomon Islands per year?
Provide a short and direct response. 1.21e+04. What is the average Number of enrolments of both sexes in St. Vincent and the Grenadines per year?
Ensure brevity in your answer.  7227.88. In the year 1971, what is the difference between the Number of enrolments of both sexes of Burundi and Number of enrolments of both sexes of Macao?
Make the answer very short. -1838. In the year 1971, what is the difference between the Number of enrolments of both sexes of Burundi and Number of enrolments of both sexes of Solomon Islands?
Give a very brief answer. 6449. In the year 1971, what is the difference between the Number of enrolments of both sexes in Burundi and Number of enrolments of both sexes in St. Vincent and the Grenadines?
Keep it short and to the point. 5011. In the year 1971, what is the difference between the Number of enrolments of both sexes of Macao and Number of enrolments of both sexes of Solomon Islands?
Your response must be concise. 8287. In the year 1971, what is the difference between the Number of enrolments of both sexes in Macao and Number of enrolments of both sexes in St. Vincent and the Grenadines?
Your response must be concise. 6849. In the year 1971, what is the difference between the Number of enrolments of both sexes in Solomon Islands and Number of enrolments of both sexes in St. Vincent and the Grenadines?
Keep it short and to the point. -1438. In the year 1972, what is the difference between the Number of enrolments of both sexes in Burundi and Number of enrolments of both sexes in Macao?
Give a very brief answer. -928. In the year 1972, what is the difference between the Number of enrolments of both sexes of Burundi and Number of enrolments of both sexes of Solomon Islands?
Provide a succinct answer. 6735. In the year 1972, what is the difference between the Number of enrolments of both sexes in Burundi and Number of enrolments of both sexes in St. Vincent and the Grenadines?
Your answer should be very brief. 4669. In the year 1972, what is the difference between the Number of enrolments of both sexes of Macao and Number of enrolments of both sexes of Solomon Islands?
Provide a short and direct response. 7663. In the year 1972, what is the difference between the Number of enrolments of both sexes in Macao and Number of enrolments of both sexes in St. Vincent and the Grenadines?
Make the answer very short. 5597. In the year 1972, what is the difference between the Number of enrolments of both sexes of Solomon Islands and Number of enrolments of both sexes of St. Vincent and the Grenadines?
Offer a very short reply. -2066. In the year 1975, what is the difference between the Number of enrolments of both sexes in Burundi and Number of enrolments of both sexes in Macao?
Your answer should be compact. 2799. In the year 1975, what is the difference between the Number of enrolments of both sexes of Burundi and Number of enrolments of both sexes of Solomon Islands?
Make the answer very short. 1.03e+04. In the year 1975, what is the difference between the Number of enrolments of both sexes in Burundi and Number of enrolments of both sexes in St. Vincent and the Grenadines?
Make the answer very short. 7419. In the year 1975, what is the difference between the Number of enrolments of both sexes of Macao and Number of enrolments of both sexes of Solomon Islands?
Your response must be concise. 7484. In the year 1975, what is the difference between the Number of enrolments of both sexes in Macao and Number of enrolments of both sexes in St. Vincent and the Grenadines?
Make the answer very short. 4620. In the year 1975, what is the difference between the Number of enrolments of both sexes of Solomon Islands and Number of enrolments of both sexes of St. Vincent and the Grenadines?
Your answer should be very brief. -2864. In the year 1976, what is the difference between the Number of enrolments of both sexes of Burundi and Number of enrolments of both sexes of Macao?
Provide a succinct answer. 1865. In the year 1976, what is the difference between the Number of enrolments of both sexes in Burundi and Number of enrolments of both sexes in Solomon Islands?
Your response must be concise. 1.09e+04. In the year 1976, what is the difference between the Number of enrolments of both sexes in Burundi and Number of enrolments of both sexes in St. Vincent and the Grenadines?
Your answer should be very brief. 8539. In the year 1976, what is the difference between the Number of enrolments of both sexes in Macao and Number of enrolments of both sexes in Solomon Islands?
Provide a short and direct response. 9033. In the year 1976, what is the difference between the Number of enrolments of both sexes in Macao and Number of enrolments of both sexes in St. Vincent and the Grenadines?
Offer a terse response. 6674. In the year 1976, what is the difference between the Number of enrolments of both sexes of Solomon Islands and Number of enrolments of both sexes of St. Vincent and the Grenadines?
Provide a succinct answer. -2359. In the year 2001, what is the difference between the Number of enrolments of both sexes in Burundi and Number of enrolments of both sexes in Macao?
Keep it short and to the point. 7.45e+04. In the year 2001, what is the difference between the Number of enrolments of both sexes of Burundi and Number of enrolments of both sexes of Solomon Islands?
Make the answer very short. 9.69e+04. In the year 2001, what is the difference between the Number of enrolments of both sexes in Burundi and Number of enrolments of both sexes in St. Vincent and the Grenadines?
Your response must be concise. 1.04e+05. In the year 2001, what is the difference between the Number of enrolments of both sexes in Macao and Number of enrolments of both sexes in Solomon Islands?
Offer a terse response. 2.25e+04. In the year 2001, what is the difference between the Number of enrolments of both sexes of Macao and Number of enrolments of both sexes of St. Vincent and the Grenadines?
Your response must be concise. 2.92e+04. In the year 2001, what is the difference between the Number of enrolments of both sexes in Solomon Islands and Number of enrolments of both sexes in St. Vincent and the Grenadines?
Your response must be concise. 6724. In the year 2002, what is the difference between the Number of enrolments of both sexes in Burundi and Number of enrolments of both sexes in Macao?
Make the answer very short. 8.05e+04. In the year 2002, what is the difference between the Number of enrolments of both sexes in Burundi and Number of enrolments of both sexes in Solomon Islands?
Your answer should be very brief. 1.01e+05. In the year 2002, what is the difference between the Number of enrolments of both sexes in Burundi and Number of enrolments of both sexes in St. Vincent and the Grenadines?
Ensure brevity in your answer.  1.13e+05. In the year 2002, what is the difference between the Number of enrolments of both sexes in Macao and Number of enrolments of both sexes in Solomon Islands?
Ensure brevity in your answer.  2.03e+04. In the year 2002, what is the difference between the Number of enrolments of both sexes of Macao and Number of enrolments of both sexes of St. Vincent and the Grenadines?
Your answer should be very brief. 3.21e+04. In the year 2002, what is the difference between the Number of enrolments of both sexes of Solomon Islands and Number of enrolments of both sexes of St. Vincent and the Grenadines?
Your answer should be very brief. 1.18e+04. In the year 2005, what is the difference between the Number of enrolments of both sexes in Burundi and Number of enrolments of both sexes in Macao?
Provide a short and direct response. 1.25e+05. In the year 2005, what is the difference between the Number of enrolments of both sexes of Burundi and Number of enrolments of both sexes of Solomon Islands?
Your answer should be very brief. 1.49e+05. In the year 2005, what is the difference between the Number of enrolments of both sexes in Burundi and Number of enrolments of both sexes in St. Vincent and the Grenadines?
Provide a succinct answer. 1.61e+05. In the year 2005, what is the difference between the Number of enrolments of both sexes in Macao and Number of enrolments of both sexes in Solomon Islands?
Make the answer very short. 2.41e+04. In the year 2005, what is the difference between the Number of enrolments of both sexes of Macao and Number of enrolments of both sexes of St. Vincent and the Grenadines?
Provide a succinct answer. 3.68e+04. In the year 2005, what is the difference between the Number of enrolments of both sexes in Solomon Islands and Number of enrolments of both sexes in St. Vincent and the Grenadines?
Your answer should be very brief. 1.27e+04. In the year 2007, what is the difference between the Number of enrolments of both sexes in Burundi and Number of enrolments of both sexes in Macao?
Offer a very short reply. 1.65e+05. In the year 2007, what is the difference between the Number of enrolments of both sexes of Burundi and Number of enrolments of both sexes of Solomon Islands?
Provide a short and direct response. 1.83e+05. In the year 2007, what is the difference between the Number of enrolments of both sexes of Burundi and Number of enrolments of both sexes of St. Vincent and the Grenadines?
Make the answer very short. 1.99e+05. In the year 2007, what is the difference between the Number of enrolments of both sexes of Macao and Number of enrolments of both sexes of Solomon Islands?
Keep it short and to the point. 1.81e+04. In the year 2007, what is the difference between the Number of enrolments of both sexes of Macao and Number of enrolments of both sexes of St. Vincent and the Grenadines?
Your answer should be compact. 3.42e+04. In the year 2007, what is the difference between the Number of enrolments of both sexes of Solomon Islands and Number of enrolments of both sexes of St. Vincent and the Grenadines?
Your answer should be very brief. 1.61e+04. What is the ratio of the Number of enrolments of both sexes of Burundi in 1971 to that in 1972?
Give a very brief answer. 0.94. What is the ratio of the Number of enrolments of both sexes of Macao in 1971 to that in 1972?
Make the answer very short. 1.04. What is the ratio of the Number of enrolments of both sexes of Solomon Islands in 1971 to that in 1972?
Your response must be concise. 0.89. What is the ratio of the Number of enrolments of both sexes in St. Vincent and the Grenadines in 1971 to that in 1972?
Offer a terse response. 0.79. What is the ratio of the Number of enrolments of both sexes of Burundi in 1971 to that in 1975?
Offer a terse response. 0.66. What is the ratio of the Number of enrolments of both sexes in Macao in 1971 to that in 1975?
Your response must be concise. 1.05. What is the ratio of the Number of enrolments of both sexes of Solomon Islands in 1971 to that in 1975?
Make the answer very short. 0.85. What is the ratio of the Number of enrolments of both sexes of St. Vincent and the Grenadines in 1971 to that in 1975?
Ensure brevity in your answer.  0.65. What is the ratio of the Number of enrolments of both sexes of Burundi in 1971 to that in 1976?
Give a very brief answer. 0.6. What is the ratio of the Number of enrolments of both sexes of Macao in 1971 to that in 1976?
Offer a terse response. 0.85. What is the ratio of the Number of enrolments of both sexes of Solomon Islands in 1971 to that in 1976?
Offer a terse response. 0.63. What is the ratio of the Number of enrolments of both sexes in St. Vincent and the Grenadines in 1971 to that in 1976?
Your answer should be compact. 0.62. What is the ratio of the Number of enrolments of both sexes of Burundi in 1971 to that in 2001?
Your answer should be very brief. 0.07. What is the ratio of the Number of enrolments of both sexes in Macao in 1971 to that in 2001?
Your response must be concise. 0.26. What is the ratio of the Number of enrolments of both sexes in Solomon Islands in 1971 to that in 2001?
Your answer should be compact. 0.1. What is the ratio of the Number of enrolments of both sexes of St. Vincent and the Grenadines in 1971 to that in 2001?
Offer a terse response. 0.32. What is the ratio of the Number of enrolments of both sexes of Burundi in 1971 to that in 2002?
Make the answer very short. 0.07. What is the ratio of the Number of enrolments of both sexes in Macao in 1971 to that in 2002?
Make the answer very short. 0.24. What is the ratio of the Number of enrolments of both sexes in Solomon Islands in 1971 to that in 2002?
Make the answer very short. 0.08. What is the ratio of the Number of enrolments of both sexes in St. Vincent and the Grenadines in 1971 to that in 2002?
Your answer should be very brief. 0.32. What is the ratio of the Number of enrolments of both sexes in Burundi in 1971 to that in 2005?
Ensure brevity in your answer.  0.05. What is the ratio of the Number of enrolments of both sexes in Macao in 1971 to that in 2005?
Your answer should be compact. 0.21. What is the ratio of the Number of enrolments of both sexes in Solomon Islands in 1971 to that in 2005?
Make the answer very short. 0.08. What is the ratio of the Number of enrolments of both sexes in St. Vincent and the Grenadines in 1971 to that in 2005?
Make the answer very short. 0.32. What is the ratio of the Number of enrolments of both sexes in Burundi in 1971 to that in 2007?
Make the answer very short. 0.04. What is the ratio of the Number of enrolments of both sexes in Macao in 1971 to that in 2007?
Offer a terse response. 0.22. What is the ratio of the Number of enrolments of both sexes in Solomon Islands in 1971 to that in 2007?
Your answer should be very brief. 0.06. What is the ratio of the Number of enrolments of both sexes in St. Vincent and the Grenadines in 1971 to that in 2007?
Your answer should be very brief. 0.28. What is the ratio of the Number of enrolments of both sexes in Burundi in 1972 to that in 1975?
Your answer should be very brief. 0.71. What is the ratio of the Number of enrolments of both sexes of Macao in 1972 to that in 1975?
Your response must be concise. 1.01. What is the ratio of the Number of enrolments of both sexes in Solomon Islands in 1972 to that in 1975?
Give a very brief answer. 0.96. What is the ratio of the Number of enrolments of both sexes of St. Vincent and the Grenadines in 1972 to that in 1975?
Ensure brevity in your answer.  0.82. What is the ratio of the Number of enrolments of both sexes of Burundi in 1972 to that in 1976?
Provide a short and direct response. 0.64. What is the ratio of the Number of enrolments of both sexes in Macao in 1972 to that in 1976?
Give a very brief answer. 0.82. What is the ratio of the Number of enrolments of both sexes in Solomon Islands in 1972 to that in 1976?
Give a very brief answer. 0.71. What is the ratio of the Number of enrolments of both sexes of St. Vincent and the Grenadines in 1972 to that in 1976?
Offer a terse response. 0.79. What is the ratio of the Number of enrolments of both sexes of Burundi in 1972 to that in 2001?
Provide a short and direct response. 0.08. What is the ratio of the Number of enrolments of both sexes of Macao in 1972 to that in 2001?
Your answer should be very brief. 0.25. What is the ratio of the Number of enrolments of both sexes in Solomon Islands in 1972 to that in 2001?
Offer a terse response. 0.12. What is the ratio of the Number of enrolments of both sexes in St. Vincent and the Grenadines in 1972 to that in 2001?
Ensure brevity in your answer.  0.41. What is the ratio of the Number of enrolments of both sexes in Burundi in 1972 to that in 2002?
Your response must be concise. 0.07. What is the ratio of the Number of enrolments of both sexes of Macao in 1972 to that in 2002?
Your response must be concise. 0.23. What is the ratio of the Number of enrolments of both sexes in Solomon Islands in 1972 to that in 2002?
Your answer should be very brief. 0.09. What is the ratio of the Number of enrolments of both sexes of St. Vincent and the Grenadines in 1972 to that in 2002?
Provide a succinct answer. 0.4. What is the ratio of the Number of enrolments of both sexes in Burundi in 1972 to that in 2005?
Offer a very short reply. 0.05. What is the ratio of the Number of enrolments of both sexes in Macao in 1972 to that in 2005?
Make the answer very short. 0.21. What is the ratio of the Number of enrolments of both sexes of Solomon Islands in 1972 to that in 2005?
Your answer should be very brief. 0.09. What is the ratio of the Number of enrolments of both sexes in St. Vincent and the Grenadines in 1972 to that in 2005?
Keep it short and to the point. 0.41. What is the ratio of the Number of enrolments of both sexes of Burundi in 1972 to that in 2007?
Your response must be concise. 0.04. What is the ratio of the Number of enrolments of both sexes in Macao in 1972 to that in 2007?
Your response must be concise. 0.21. What is the ratio of the Number of enrolments of both sexes in Solomon Islands in 1972 to that in 2007?
Give a very brief answer. 0.07. What is the ratio of the Number of enrolments of both sexes in St. Vincent and the Grenadines in 1972 to that in 2007?
Ensure brevity in your answer.  0.36. What is the ratio of the Number of enrolments of both sexes in Burundi in 1975 to that in 1976?
Offer a very short reply. 0.9. What is the ratio of the Number of enrolments of both sexes in Macao in 1975 to that in 1976?
Give a very brief answer. 0.81. What is the ratio of the Number of enrolments of both sexes in Solomon Islands in 1975 to that in 1976?
Give a very brief answer. 0.74. What is the ratio of the Number of enrolments of both sexes of St. Vincent and the Grenadines in 1975 to that in 1976?
Your answer should be compact. 0.96. What is the ratio of the Number of enrolments of both sexes in Burundi in 1975 to that in 2001?
Your answer should be compact. 0.11. What is the ratio of the Number of enrolments of both sexes of Macao in 1975 to that in 2001?
Ensure brevity in your answer.  0.24. What is the ratio of the Number of enrolments of both sexes in Solomon Islands in 1975 to that in 2001?
Your answer should be compact. 0.12. What is the ratio of the Number of enrolments of both sexes in Burundi in 1975 to that in 2002?
Ensure brevity in your answer.  0.1. What is the ratio of the Number of enrolments of both sexes in Macao in 1975 to that in 2002?
Your response must be concise. 0.23. What is the ratio of the Number of enrolments of both sexes of Solomon Islands in 1975 to that in 2002?
Offer a terse response. 0.09. What is the ratio of the Number of enrolments of both sexes of St. Vincent and the Grenadines in 1975 to that in 2002?
Provide a short and direct response. 0.49. What is the ratio of the Number of enrolments of both sexes in Burundi in 1975 to that in 2005?
Your answer should be compact. 0.07. What is the ratio of the Number of enrolments of both sexes of Macao in 1975 to that in 2005?
Provide a succinct answer. 0.2. What is the ratio of the Number of enrolments of both sexes in Solomon Islands in 1975 to that in 2005?
Make the answer very short. 0.09. What is the ratio of the Number of enrolments of both sexes of St. Vincent and the Grenadines in 1975 to that in 2005?
Provide a short and direct response. 0.5. What is the ratio of the Number of enrolments of both sexes in Burundi in 1975 to that in 2007?
Provide a short and direct response. 0.06. What is the ratio of the Number of enrolments of both sexes in Macao in 1975 to that in 2007?
Give a very brief answer. 0.21. What is the ratio of the Number of enrolments of both sexes in Solomon Islands in 1975 to that in 2007?
Your answer should be compact. 0.07. What is the ratio of the Number of enrolments of both sexes in St. Vincent and the Grenadines in 1975 to that in 2007?
Give a very brief answer. 0.43. What is the ratio of the Number of enrolments of both sexes in Burundi in 1976 to that in 2001?
Give a very brief answer. 0.12. What is the ratio of the Number of enrolments of both sexes in Macao in 1976 to that in 2001?
Offer a very short reply. 0.3. What is the ratio of the Number of enrolments of both sexes of Solomon Islands in 1976 to that in 2001?
Provide a short and direct response. 0.17. What is the ratio of the Number of enrolments of both sexes of St. Vincent and the Grenadines in 1976 to that in 2001?
Offer a terse response. 0.52. What is the ratio of the Number of enrolments of both sexes in Burundi in 1976 to that in 2002?
Make the answer very short. 0.11. What is the ratio of the Number of enrolments of both sexes in Macao in 1976 to that in 2002?
Provide a short and direct response. 0.28. What is the ratio of the Number of enrolments of both sexes of Solomon Islands in 1976 to that in 2002?
Offer a terse response. 0.13. What is the ratio of the Number of enrolments of both sexes in St. Vincent and the Grenadines in 1976 to that in 2002?
Provide a succinct answer. 0.51. What is the ratio of the Number of enrolments of both sexes of Burundi in 1976 to that in 2005?
Ensure brevity in your answer.  0.08. What is the ratio of the Number of enrolments of both sexes of Macao in 1976 to that in 2005?
Ensure brevity in your answer.  0.25. What is the ratio of the Number of enrolments of both sexes of Solomon Islands in 1976 to that in 2005?
Provide a succinct answer. 0.12. What is the ratio of the Number of enrolments of both sexes of St. Vincent and the Grenadines in 1976 to that in 2005?
Provide a succinct answer. 0.52. What is the ratio of the Number of enrolments of both sexes in Burundi in 1976 to that in 2007?
Ensure brevity in your answer.  0.06. What is the ratio of the Number of enrolments of both sexes of Macao in 1976 to that in 2007?
Offer a very short reply. 0.26. What is the ratio of the Number of enrolments of both sexes in Solomon Islands in 1976 to that in 2007?
Your response must be concise. 0.1. What is the ratio of the Number of enrolments of both sexes in St. Vincent and the Grenadines in 1976 to that in 2007?
Offer a very short reply. 0.45. What is the ratio of the Number of enrolments of both sexes of Burundi in 2001 to that in 2002?
Offer a terse response. 0.93. What is the ratio of the Number of enrolments of both sexes of Macao in 2001 to that in 2002?
Your answer should be very brief. 0.93. What is the ratio of the Number of enrolments of both sexes in Solomon Islands in 2001 to that in 2002?
Ensure brevity in your answer.  0.76. What is the ratio of the Number of enrolments of both sexes in St. Vincent and the Grenadines in 2001 to that in 2002?
Give a very brief answer. 0.98. What is the ratio of the Number of enrolments of both sexes in Burundi in 2001 to that in 2005?
Give a very brief answer. 0.66. What is the ratio of the Number of enrolments of both sexes in Macao in 2001 to that in 2005?
Keep it short and to the point. 0.84. What is the ratio of the Number of enrolments of both sexes of Solomon Islands in 2001 to that in 2005?
Give a very brief answer. 0.73. What is the ratio of the Number of enrolments of both sexes in Burundi in 2001 to that in 2007?
Provide a succinct answer. 0.54. What is the ratio of the Number of enrolments of both sexes in Macao in 2001 to that in 2007?
Give a very brief answer. 0.86. What is the ratio of the Number of enrolments of both sexes of Solomon Islands in 2001 to that in 2007?
Your answer should be very brief. 0.6. What is the ratio of the Number of enrolments of both sexes of St. Vincent and the Grenadines in 2001 to that in 2007?
Offer a terse response. 0.87. What is the ratio of the Number of enrolments of both sexes in Burundi in 2002 to that in 2005?
Provide a short and direct response. 0.72. What is the ratio of the Number of enrolments of both sexes in Macao in 2002 to that in 2005?
Give a very brief answer. 0.9. What is the ratio of the Number of enrolments of both sexes of Solomon Islands in 2002 to that in 2005?
Offer a terse response. 0.96. What is the ratio of the Number of enrolments of both sexes in St. Vincent and the Grenadines in 2002 to that in 2005?
Your answer should be compact. 1.01. What is the ratio of the Number of enrolments of both sexes in Burundi in 2002 to that in 2007?
Ensure brevity in your answer.  0.58. What is the ratio of the Number of enrolments of both sexes in Macao in 2002 to that in 2007?
Your answer should be compact. 0.93. What is the ratio of the Number of enrolments of both sexes in Solomon Islands in 2002 to that in 2007?
Make the answer very short. 0.79. What is the ratio of the Number of enrolments of both sexes of St. Vincent and the Grenadines in 2002 to that in 2007?
Your response must be concise. 0.88. What is the ratio of the Number of enrolments of both sexes of Burundi in 2005 to that in 2007?
Provide a short and direct response. 0.81. What is the ratio of the Number of enrolments of both sexes of Macao in 2005 to that in 2007?
Keep it short and to the point. 1.02. What is the ratio of the Number of enrolments of both sexes of Solomon Islands in 2005 to that in 2007?
Your response must be concise. 0.82. What is the ratio of the Number of enrolments of both sexes of St. Vincent and the Grenadines in 2005 to that in 2007?
Provide a succinct answer. 0.87. What is the difference between the highest and the second highest Number of enrolments of both sexes in Burundi?
Your answer should be compact. 3.88e+04. What is the difference between the highest and the second highest Number of enrolments of both sexes in Macao?
Provide a short and direct response. 1129. What is the difference between the highest and the second highest Number of enrolments of both sexes in Solomon Islands?
Make the answer very short. 4845. What is the difference between the highest and the second highest Number of enrolments of both sexes of St. Vincent and the Grenadines?
Keep it short and to the point. 1318. What is the difference between the highest and the lowest Number of enrolments of both sexes of Burundi?
Your response must be concise. 2.02e+05. What is the difference between the highest and the lowest Number of enrolments of both sexes of Macao?
Provide a succinct answer. 3.70e+04. What is the difference between the highest and the lowest Number of enrolments of both sexes of Solomon Islands?
Ensure brevity in your answer.  2.56e+04. What is the difference between the highest and the lowest Number of enrolments of both sexes of St. Vincent and the Grenadines?
Make the answer very short. 8080. 